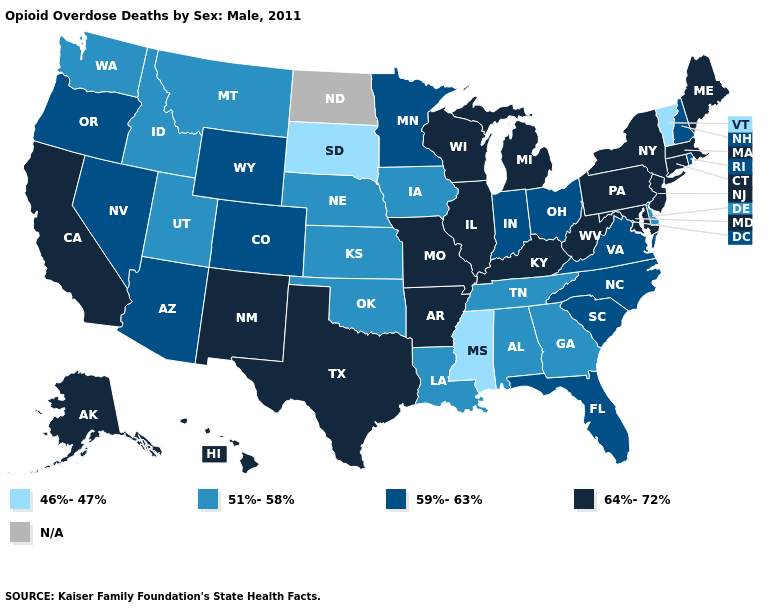Is the legend a continuous bar?
Write a very short answer. No. What is the value of South Dakota?
Short answer required. 46%-47%. How many symbols are there in the legend?
Keep it brief. 5. What is the value of Hawaii?
Write a very short answer. 64%-72%. Name the states that have a value in the range 59%-63%?
Be succinct. Arizona, Colorado, Florida, Indiana, Minnesota, Nevada, New Hampshire, North Carolina, Ohio, Oregon, Rhode Island, South Carolina, Virginia, Wyoming. Does Kentucky have the highest value in the USA?
Concise answer only. Yes. Which states have the highest value in the USA?
Short answer required. Alaska, Arkansas, California, Connecticut, Hawaii, Illinois, Kentucky, Maine, Maryland, Massachusetts, Michigan, Missouri, New Jersey, New Mexico, New York, Pennsylvania, Texas, West Virginia, Wisconsin. What is the highest value in the USA?
Concise answer only. 64%-72%. Which states have the highest value in the USA?
Be succinct. Alaska, Arkansas, California, Connecticut, Hawaii, Illinois, Kentucky, Maine, Maryland, Massachusetts, Michigan, Missouri, New Jersey, New Mexico, New York, Pennsylvania, Texas, West Virginia, Wisconsin. What is the lowest value in states that border Delaware?
Keep it brief. 64%-72%. Among the states that border West Virginia , does Ohio have the lowest value?
Be succinct. Yes. What is the highest value in the South ?
Give a very brief answer. 64%-72%. What is the value of Mississippi?
Keep it brief. 46%-47%. What is the highest value in states that border New Hampshire?
Concise answer only. 64%-72%. 